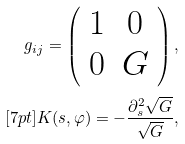Convert formula to latex. <formula><loc_0><loc_0><loc_500><loc_500>g _ { i j } = \left ( \begin{array} { c c } 1 & 0 \\ 0 & G \end{array} \right ) , \\ [ 7 p t ] K ( s , \varphi ) = - \frac { \partial _ { s } ^ { 2 } \sqrt { G } } { \sqrt { G } } ,</formula> 